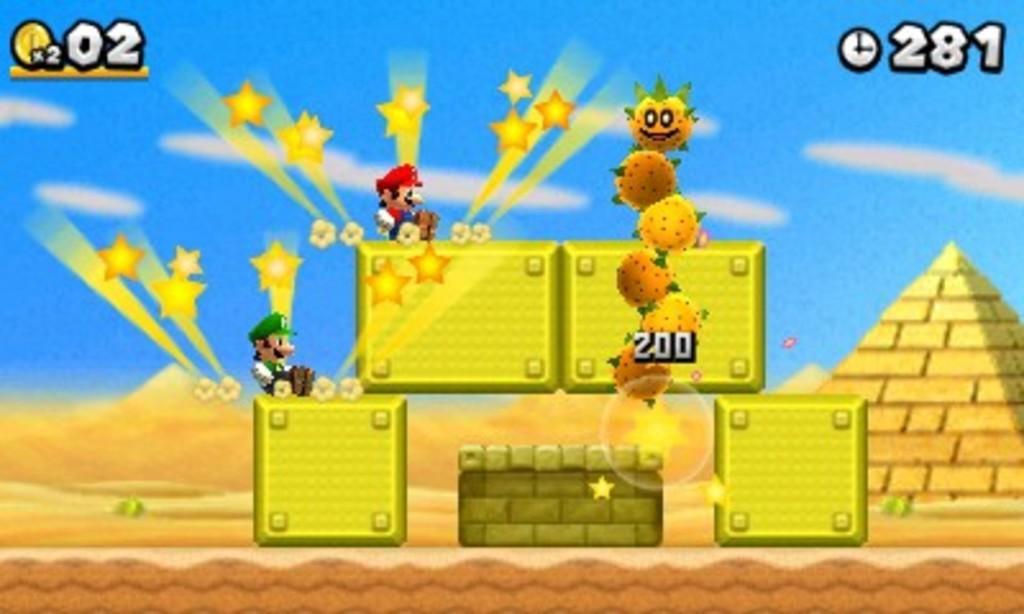In one or two sentences, can you explain what this image depicts? In this image, we can see a game screen contains depiction of persons, stars, walls and numbers. 